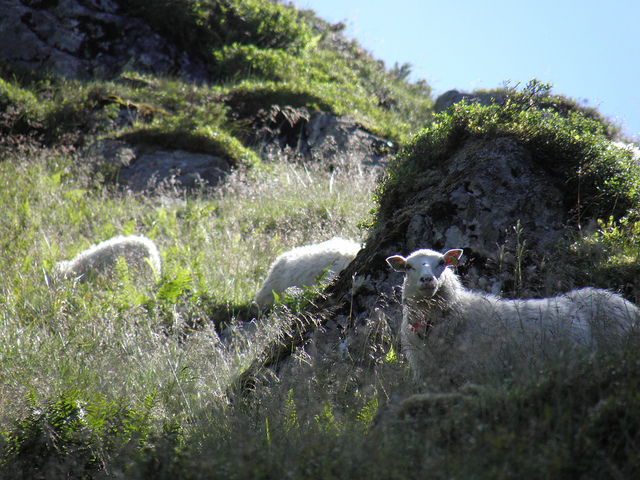Are there any other animals or people in the photo? Based on the image provided, there are no visible animals other than the three sheep, nor are there any people in the frame. The area is devoid of human structures or signs of human activity, which contributes to the natural and undisturbed ambiance of the setting. 